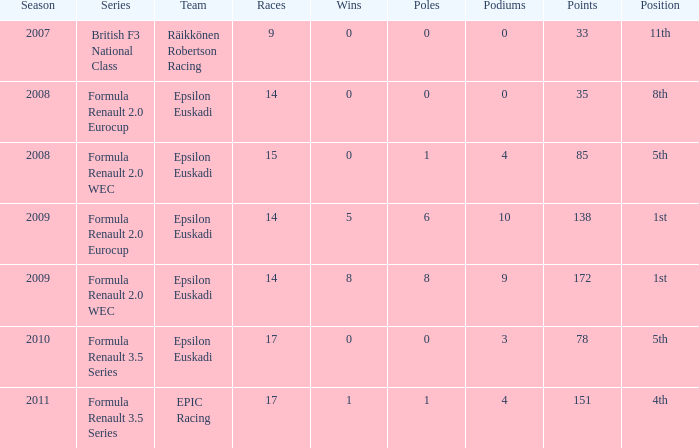What team was he on when he had 10 f/laps? Epsilon Euskadi. 